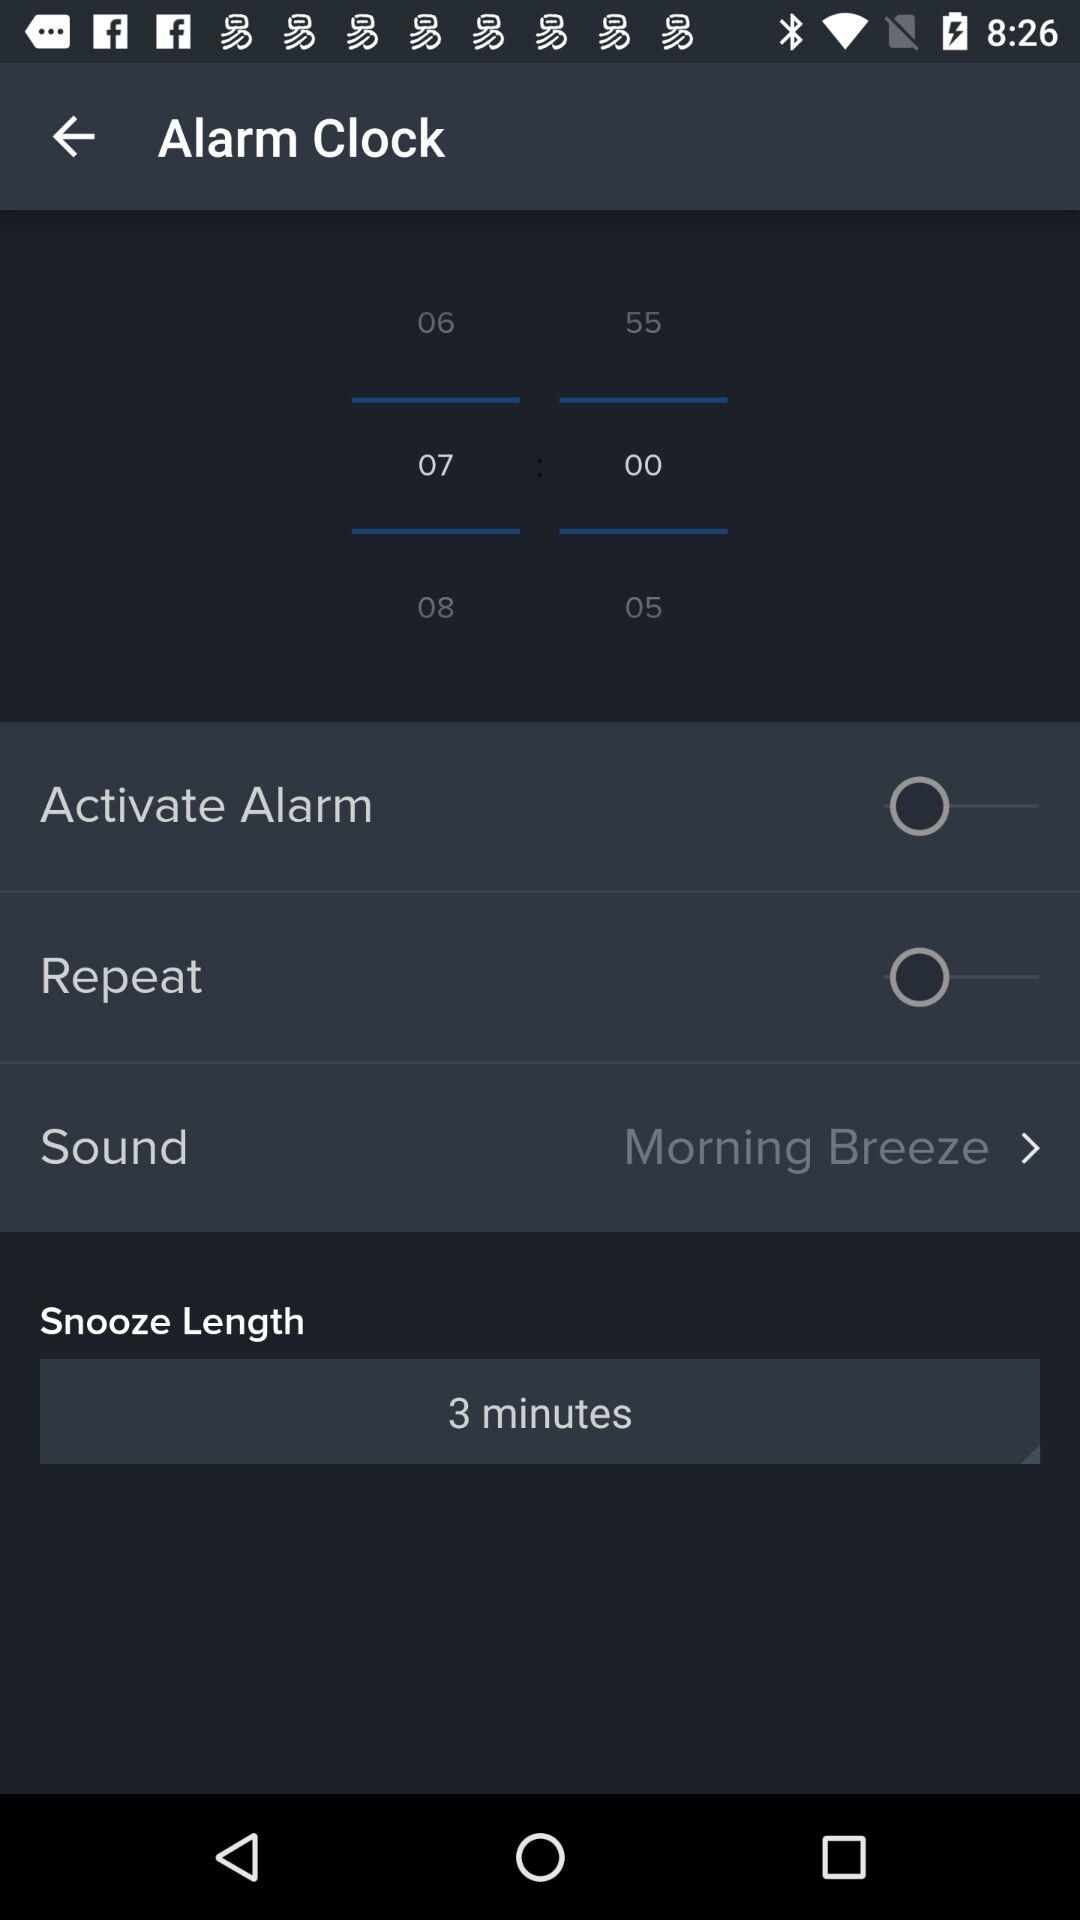What is the selected snooze length? The selected snooze length is 3 minutes. 